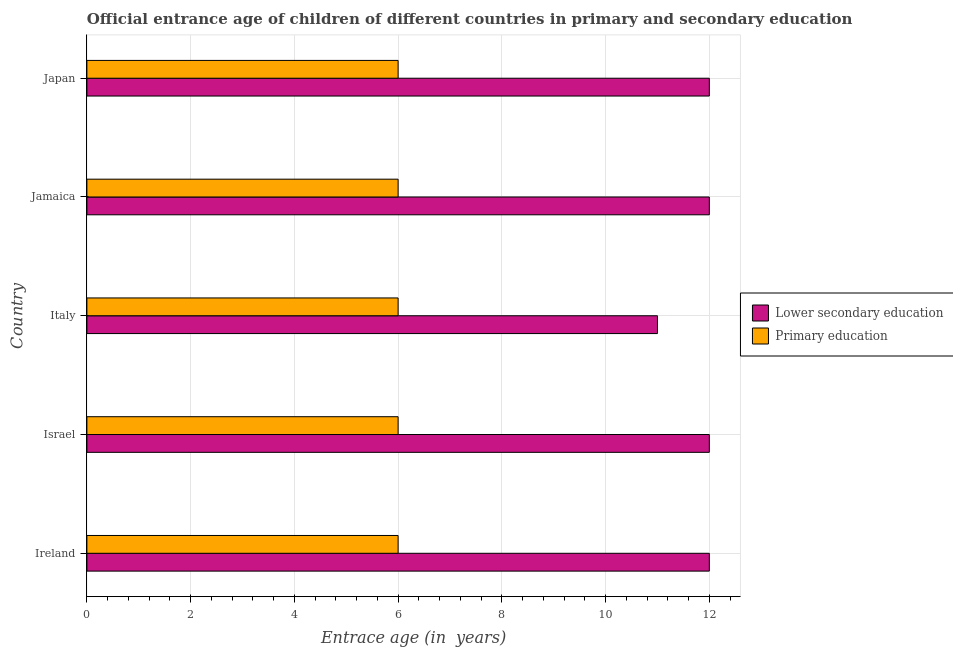How many groups of bars are there?
Make the answer very short. 5. Are the number of bars per tick equal to the number of legend labels?
Your response must be concise. Yes. How many bars are there on the 3rd tick from the top?
Ensure brevity in your answer.  2. How many bars are there on the 4th tick from the bottom?
Ensure brevity in your answer.  2. What is the label of the 4th group of bars from the top?
Your answer should be compact. Israel. What is the entrance age of chiildren in primary education in Italy?
Make the answer very short. 6. Across all countries, what is the maximum entrance age of chiildren in primary education?
Keep it short and to the point. 6. Across all countries, what is the minimum entrance age of children in lower secondary education?
Your response must be concise. 11. In which country was the entrance age of children in lower secondary education maximum?
Provide a short and direct response. Ireland. In which country was the entrance age of chiildren in primary education minimum?
Provide a short and direct response. Ireland. What is the total entrance age of chiildren in primary education in the graph?
Your answer should be compact. 30. What is the difference between the entrance age of chiildren in primary education in Israel and that in Japan?
Ensure brevity in your answer.  0. What is the difference between the entrance age of chiildren in primary education in Jamaica and the entrance age of children in lower secondary education in Ireland?
Provide a short and direct response. -6. In how many countries, is the entrance age of chiildren in primary education greater than 4.8 years?
Offer a terse response. 5. What is the ratio of the entrance age of chiildren in primary education in Italy to that in Japan?
Provide a short and direct response. 1. Is the difference between the entrance age of children in lower secondary education in Jamaica and Japan greater than the difference between the entrance age of chiildren in primary education in Jamaica and Japan?
Offer a very short reply. No. What is the difference between the highest and the lowest entrance age of children in lower secondary education?
Offer a terse response. 1. Is the sum of the entrance age of children in lower secondary education in Israel and Japan greater than the maximum entrance age of chiildren in primary education across all countries?
Offer a terse response. Yes. What does the 2nd bar from the bottom in Jamaica represents?
Ensure brevity in your answer.  Primary education. How many bars are there?
Provide a short and direct response. 10. Are all the bars in the graph horizontal?
Ensure brevity in your answer.  Yes. Are the values on the major ticks of X-axis written in scientific E-notation?
Provide a succinct answer. No. Where does the legend appear in the graph?
Make the answer very short. Center right. How are the legend labels stacked?
Offer a terse response. Vertical. What is the title of the graph?
Ensure brevity in your answer.  Official entrance age of children of different countries in primary and secondary education. Does "Constant 2005 US$" appear as one of the legend labels in the graph?
Your answer should be compact. No. What is the label or title of the X-axis?
Your response must be concise. Entrace age (in  years). What is the Entrace age (in  years) in Lower secondary education in Italy?
Offer a terse response. 11. What is the Entrace age (in  years) in Primary education in Jamaica?
Provide a succinct answer. 6. What is the Entrace age (in  years) in Lower secondary education in Japan?
Keep it short and to the point. 12. Across all countries, what is the maximum Entrace age (in  years) in Lower secondary education?
Your answer should be compact. 12. Across all countries, what is the maximum Entrace age (in  years) in Primary education?
Make the answer very short. 6. Across all countries, what is the minimum Entrace age (in  years) in Primary education?
Your answer should be compact. 6. What is the total Entrace age (in  years) in Lower secondary education in the graph?
Offer a very short reply. 59. What is the difference between the Entrace age (in  years) of Lower secondary education in Ireland and that in Israel?
Provide a succinct answer. 0. What is the difference between the Entrace age (in  years) in Primary education in Ireland and that in Israel?
Keep it short and to the point. 0. What is the difference between the Entrace age (in  years) in Lower secondary education in Ireland and that in Italy?
Give a very brief answer. 1. What is the difference between the Entrace age (in  years) of Lower secondary education in Ireland and that in Jamaica?
Ensure brevity in your answer.  0. What is the difference between the Entrace age (in  years) in Primary education in Ireland and that in Jamaica?
Offer a terse response. 0. What is the difference between the Entrace age (in  years) in Lower secondary education in Ireland and that in Japan?
Your answer should be very brief. 0. What is the difference between the Entrace age (in  years) of Primary education in Israel and that in Italy?
Give a very brief answer. 0. What is the difference between the Entrace age (in  years) of Primary education in Israel and that in Jamaica?
Give a very brief answer. 0. What is the difference between the Entrace age (in  years) in Primary education in Israel and that in Japan?
Offer a very short reply. 0. What is the difference between the Entrace age (in  years) in Lower secondary education in Italy and that in Japan?
Your answer should be compact. -1. What is the difference between the Entrace age (in  years) in Lower secondary education in Jamaica and that in Japan?
Make the answer very short. 0. What is the difference between the Entrace age (in  years) in Lower secondary education in Ireland and the Entrace age (in  years) in Primary education in Israel?
Offer a terse response. 6. What is the difference between the Entrace age (in  years) of Lower secondary education in Ireland and the Entrace age (in  years) of Primary education in Italy?
Your answer should be very brief. 6. What is the difference between the Entrace age (in  years) of Lower secondary education in Ireland and the Entrace age (in  years) of Primary education in Jamaica?
Your answer should be compact. 6. What is the difference between the Entrace age (in  years) in Lower secondary education in Italy and the Entrace age (in  years) in Primary education in Jamaica?
Offer a terse response. 5. What is the difference between the Entrace age (in  years) in Lower secondary education in Italy and the Entrace age (in  years) in Primary education in Japan?
Your response must be concise. 5. What is the difference between the Entrace age (in  years) of Lower secondary education in Jamaica and the Entrace age (in  years) of Primary education in Japan?
Make the answer very short. 6. What is the average Entrace age (in  years) in Primary education per country?
Offer a very short reply. 6. What is the difference between the Entrace age (in  years) in Lower secondary education and Entrace age (in  years) in Primary education in Israel?
Your answer should be compact. 6. What is the ratio of the Entrace age (in  years) of Lower secondary education in Ireland to that in Italy?
Offer a terse response. 1.09. What is the ratio of the Entrace age (in  years) in Lower secondary education in Ireland to that in Jamaica?
Offer a very short reply. 1. What is the ratio of the Entrace age (in  years) of Primary education in Ireland to that in Jamaica?
Offer a very short reply. 1. What is the ratio of the Entrace age (in  years) in Lower secondary education in Israel to that in Italy?
Your response must be concise. 1.09. What is the ratio of the Entrace age (in  years) of Primary education in Israel to that in Jamaica?
Provide a succinct answer. 1. What is the ratio of the Entrace age (in  years) of Lower secondary education in Italy to that in Jamaica?
Provide a succinct answer. 0.92. What is the ratio of the Entrace age (in  years) in Lower secondary education in Italy to that in Japan?
Your response must be concise. 0.92. What is the ratio of the Entrace age (in  years) in Lower secondary education in Jamaica to that in Japan?
Provide a short and direct response. 1. What is the ratio of the Entrace age (in  years) of Primary education in Jamaica to that in Japan?
Your response must be concise. 1. What is the difference between the highest and the second highest Entrace age (in  years) in Primary education?
Your response must be concise. 0. 